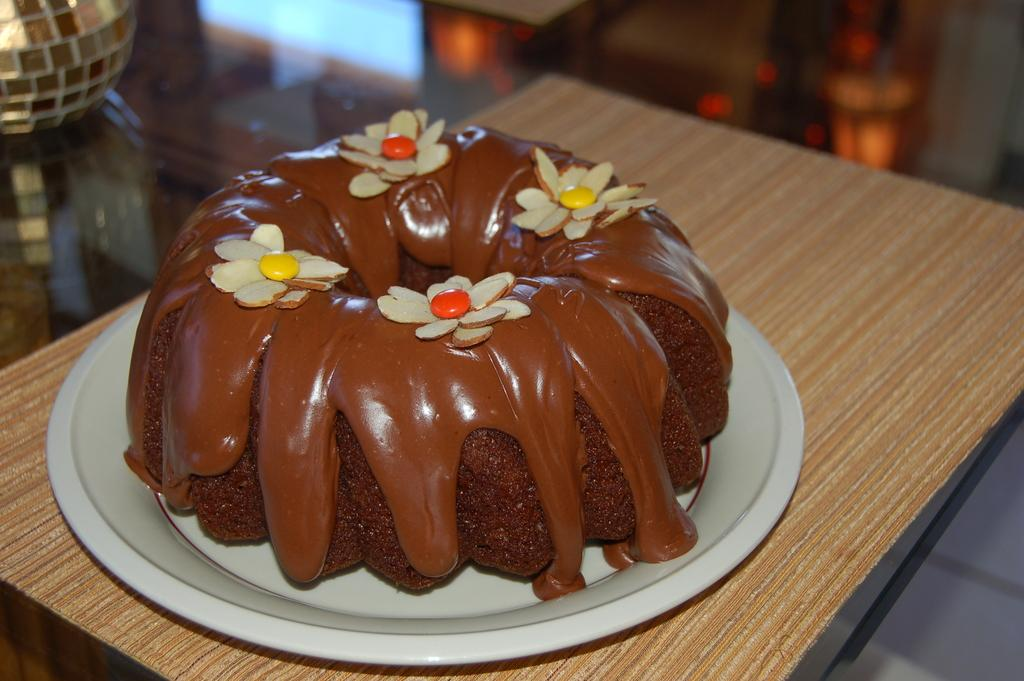What type of cake is shown in the image? There is a chocolate collar cake in the image. What is the cake placed on? The cake is on a white color plate. What type of pet can be seen interacting with the cake in the image? There is no pet present in the image; it only shows a chocolate collar cake on a white color plate. 